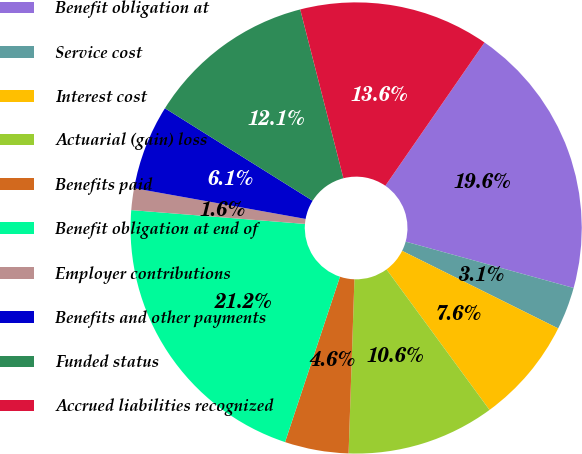<chart> <loc_0><loc_0><loc_500><loc_500><pie_chart><fcel>Benefit obligation at<fcel>Service cost<fcel>Interest cost<fcel>Actuarial (gain) loss<fcel>Benefits paid<fcel>Benefit obligation at end of<fcel>Employer contributions<fcel>Benefits and other payments<fcel>Funded status<fcel>Accrued liabilities recognized<nl><fcel>19.65%<fcel>3.06%<fcel>7.59%<fcel>10.6%<fcel>4.57%<fcel>21.16%<fcel>1.56%<fcel>6.08%<fcel>12.11%<fcel>13.62%<nl></chart> 